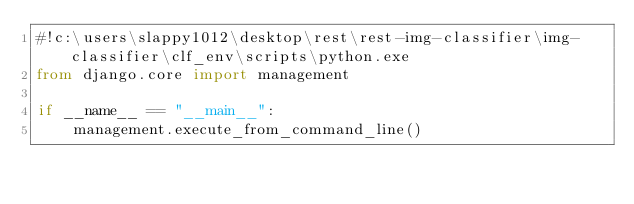Convert code to text. <code><loc_0><loc_0><loc_500><loc_500><_Python_>#!c:\users\slappy1012\desktop\rest\rest-img-classifier\img-classifier\clf_env\scripts\python.exe
from django.core import management

if __name__ == "__main__":
    management.execute_from_command_line()
</code> 